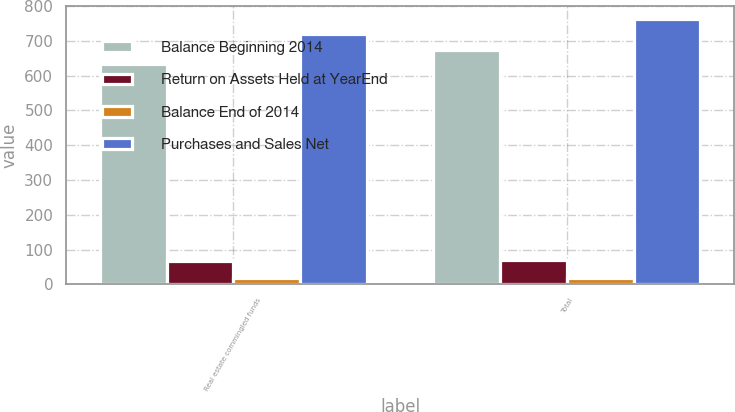<chart> <loc_0><loc_0><loc_500><loc_500><stacked_bar_chart><ecel><fcel>Real estate commingled funds<fcel>Total<nl><fcel>Balance Beginning 2014<fcel>635<fcel>675<nl><fcel>Return on Assets Held at YearEnd<fcel>68<fcel>70<nl><fcel>Balance End of 2014<fcel>18<fcel>18<nl><fcel>Purchases and Sales Net<fcel>721<fcel>763<nl></chart> 